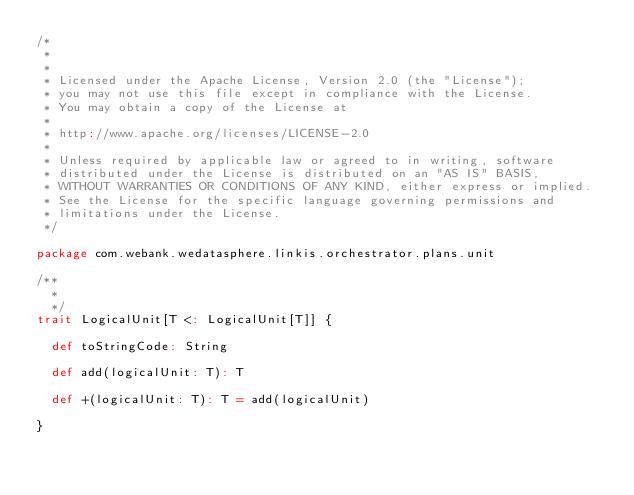Convert code to text. <code><loc_0><loc_0><loc_500><loc_500><_Scala_>/*
 *
 *
 * Licensed under the Apache License, Version 2.0 (the "License");
 * you may not use this file except in compliance with the License.
 * You may obtain a copy of the License at
 *
 * http://www.apache.org/licenses/LICENSE-2.0
 *
 * Unless required by applicable law or agreed to in writing, software
 * distributed under the License is distributed on an "AS IS" BASIS,
 * WITHOUT WARRANTIES OR CONDITIONS OF ANY KIND, either express or implied.
 * See the License for the specific language governing permissions and
 * limitations under the License.
 */

package com.webank.wedatasphere.linkis.orchestrator.plans.unit

/**
  *
  */
trait LogicalUnit[T <: LogicalUnit[T]] {

  def toStringCode: String

  def add(logicalUnit: T): T

  def +(logicalUnit: T): T = add(logicalUnit)

}
</code> 